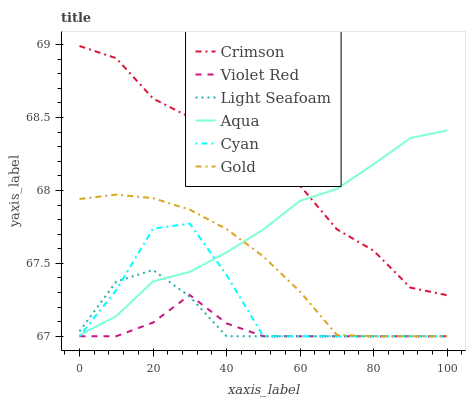Does Violet Red have the minimum area under the curve?
Answer yes or no. Yes. Does Crimson have the maximum area under the curve?
Answer yes or no. Yes. Does Gold have the minimum area under the curve?
Answer yes or no. No. Does Gold have the maximum area under the curve?
Answer yes or no. No. Is Gold the smoothest?
Answer yes or no. Yes. Is Cyan the roughest?
Answer yes or no. Yes. Is Aqua the smoothest?
Answer yes or no. No. Is Aqua the roughest?
Answer yes or no. No. Does Violet Red have the lowest value?
Answer yes or no. Yes. Does Aqua have the lowest value?
Answer yes or no. No. Does Crimson have the highest value?
Answer yes or no. Yes. Does Gold have the highest value?
Answer yes or no. No. Is Cyan less than Crimson?
Answer yes or no. Yes. Is Aqua greater than Violet Red?
Answer yes or no. Yes. Does Light Seafoam intersect Aqua?
Answer yes or no. Yes. Is Light Seafoam less than Aqua?
Answer yes or no. No. Is Light Seafoam greater than Aqua?
Answer yes or no. No. Does Cyan intersect Crimson?
Answer yes or no. No. 